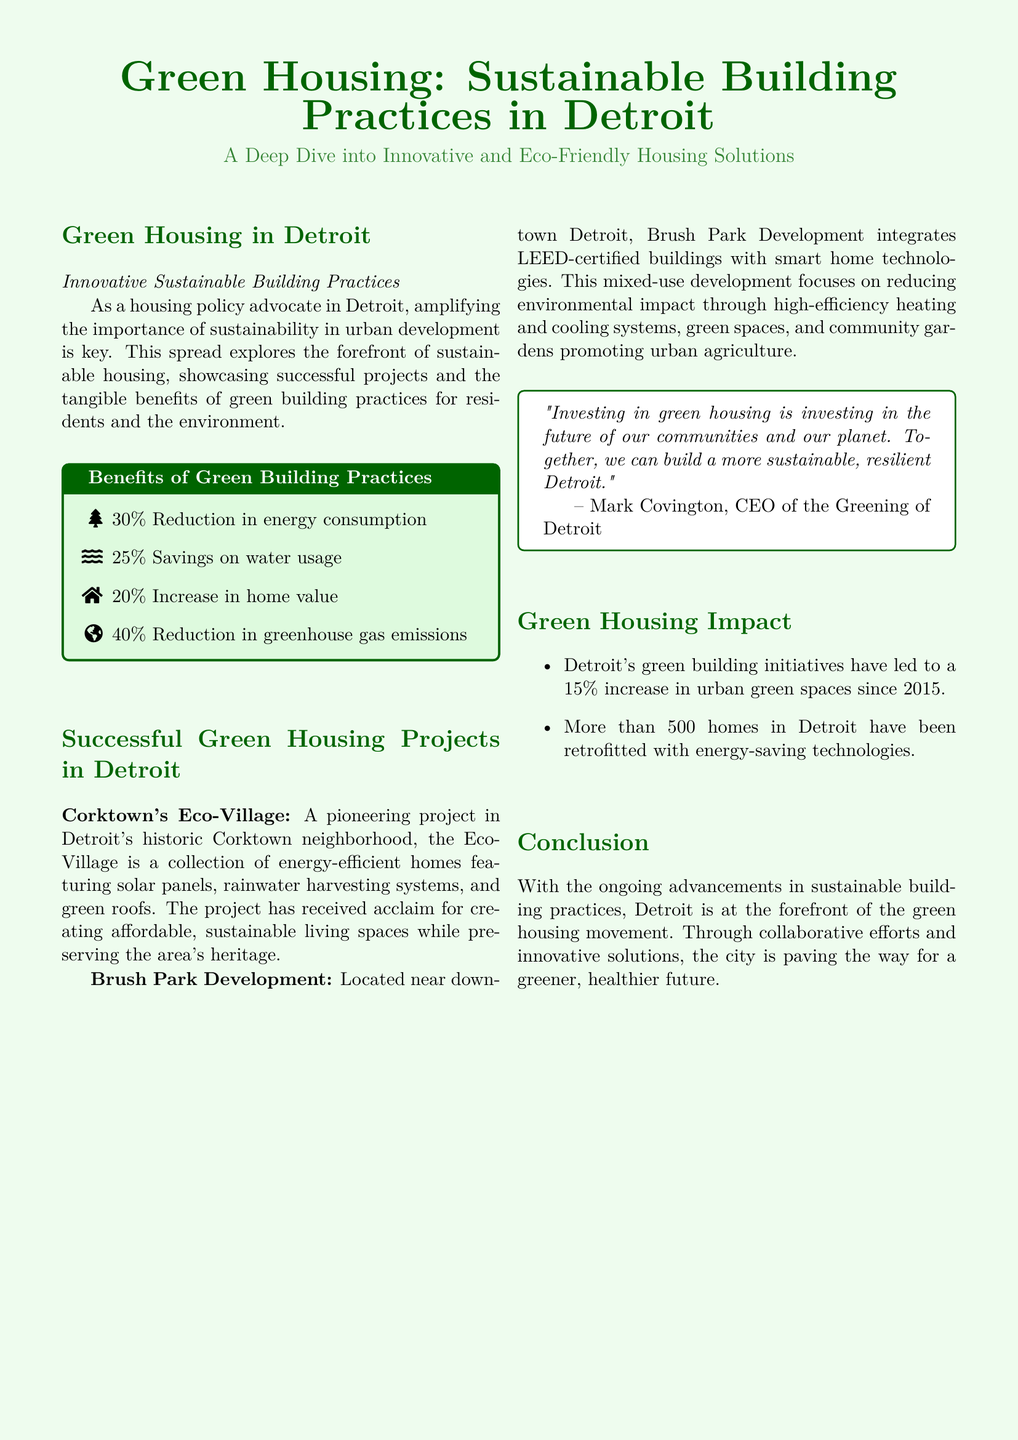what is the title of the document? The title is prominently featured at the top of the document, clearly stating the focus on green housing.
Answer: Green Housing: Sustainable Building Practices in Detroit what is the percentage reduction in energy consumption due to green building practices? The document highlights specific benefits of green building practices including energy savings.
Answer: 30% what project is mentioned as being located in Corktown? The document provides information about innovative housing projects located in specific neighborhoods in Detroit.
Answer: Corktown's Eco-Village how much have green building initiatives in Detroit increased urban green spaces since 2015? The document lists impacts of green housing initiatives, including urban green space increases.
Answer: 15% who is the CEO of the Greening of Detroit? A notable quote in the document identifies the individual and their role in promoting green housing.
Answer: Mark Covington what type of saving is reported to be 25%? The document provides numerical benefits related to green building practices, including savings percentages.
Answer: Water usage what type of development is the Brush Park Development? Information about the nature and focus of the development is explained in the successful projects section.
Answer: Mixed-use development what is the impact of retrofitting homes with energy-saving technologies? The document states the number of homes involved in sustainable retrofitting efforts in Detroit.
Answer: More than 500 homes what color theme is used in the document? The document features specific color choices that enhance its visual appeal and thematic relevance.
Answer: Green 